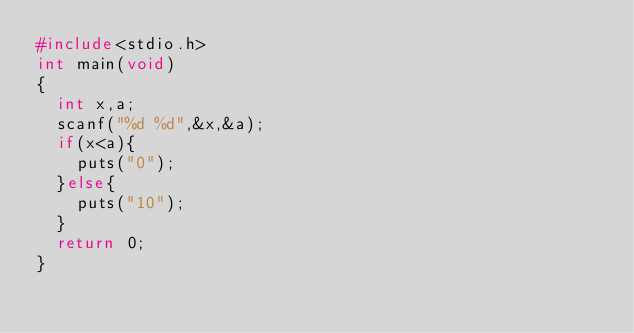<code> <loc_0><loc_0><loc_500><loc_500><_C_>#include<stdio.h>
int main(void)
{
  int x,a;
  scanf("%d %d",&x,&a);
  if(x<a){
    puts("0");
  }else{
    puts("10");
  }
  return 0;
}
</code> 